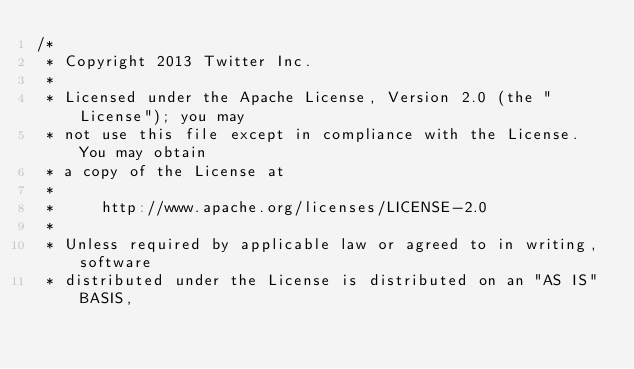<code> <loc_0><loc_0><loc_500><loc_500><_Scala_>/*
 * Copyright 2013 Twitter Inc.
 *
 * Licensed under the Apache License, Version 2.0 (the "License"); you may
 * not use this file except in compliance with the License. You may obtain
 * a copy of the License at
 *
 *     http://www.apache.org/licenses/LICENSE-2.0
 *
 * Unless required by applicable law or agreed to in writing, software
 * distributed under the License is distributed on an "AS IS" BASIS,</code> 